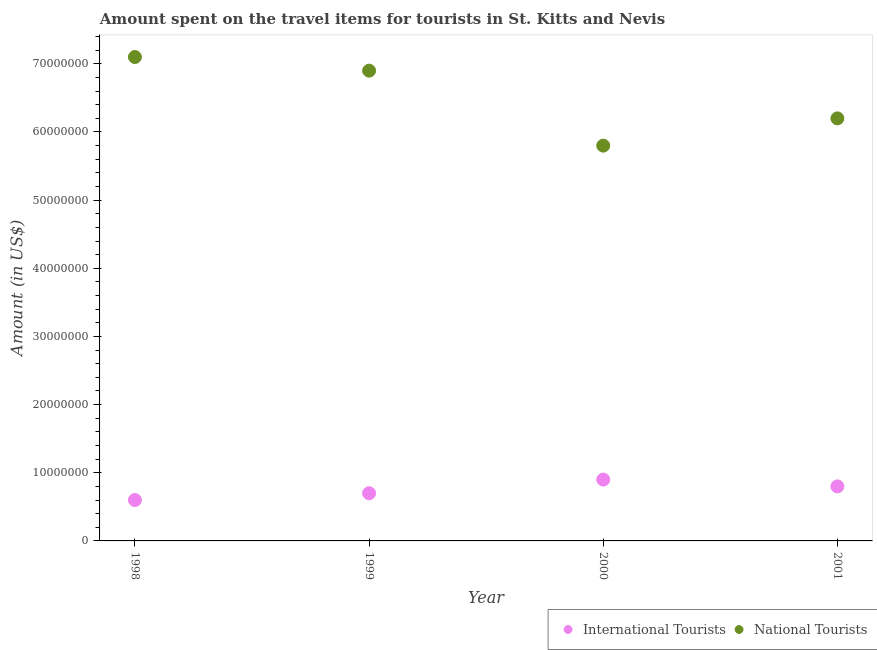How many different coloured dotlines are there?
Ensure brevity in your answer.  2. Is the number of dotlines equal to the number of legend labels?
Keep it short and to the point. Yes. What is the amount spent on travel items of international tourists in 1999?
Your answer should be very brief. 7.00e+06. Across all years, what is the maximum amount spent on travel items of international tourists?
Offer a terse response. 9.00e+06. Across all years, what is the minimum amount spent on travel items of international tourists?
Give a very brief answer. 6.00e+06. In which year was the amount spent on travel items of international tourists minimum?
Your answer should be compact. 1998. What is the total amount spent on travel items of national tourists in the graph?
Provide a succinct answer. 2.60e+08. What is the difference between the amount spent on travel items of national tourists in 1999 and that in 2000?
Keep it short and to the point. 1.10e+07. What is the difference between the amount spent on travel items of international tourists in 2001 and the amount spent on travel items of national tourists in 1998?
Keep it short and to the point. -6.30e+07. What is the average amount spent on travel items of international tourists per year?
Provide a succinct answer. 7.50e+06. In the year 1998, what is the difference between the amount spent on travel items of international tourists and amount spent on travel items of national tourists?
Provide a succinct answer. -6.50e+07. What is the ratio of the amount spent on travel items of international tourists in 1998 to that in 2000?
Ensure brevity in your answer.  0.67. Is the amount spent on travel items of national tourists in 1998 less than that in 1999?
Your answer should be compact. No. What is the difference between the highest and the second highest amount spent on travel items of international tourists?
Offer a very short reply. 1.00e+06. What is the difference between the highest and the lowest amount spent on travel items of international tourists?
Offer a very short reply. 3.00e+06. In how many years, is the amount spent on travel items of national tourists greater than the average amount spent on travel items of national tourists taken over all years?
Offer a very short reply. 2. Does the amount spent on travel items of national tourists monotonically increase over the years?
Your response must be concise. No. How many years are there in the graph?
Offer a terse response. 4. Are the values on the major ticks of Y-axis written in scientific E-notation?
Provide a short and direct response. No. Does the graph contain grids?
Make the answer very short. No. Where does the legend appear in the graph?
Offer a very short reply. Bottom right. How are the legend labels stacked?
Keep it short and to the point. Horizontal. What is the title of the graph?
Ensure brevity in your answer.  Amount spent on the travel items for tourists in St. Kitts and Nevis. Does "Manufacturing industries and construction" appear as one of the legend labels in the graph?
Your response must be concise. No. What is the label or title of the X-axis?
Offer a terse response. Year. What is the Amount (in US$) in National Tourists in 1998?
Give a very brief answer. 7.10e+07. What is the Amount (in US$) in International Tourists in 1999?
Your answer should be very brief. 7.00e+06. What is the Amount (in US$) in National Tourists in 1999?
Offer a very short reply. 6.90e+07. What is the Amount (in US$) in International Tourists in 2000?
Make the answer very short. 9.00e+06. What is the Amount (in US$) of National Tourists in 2000?
Give a very brief answer. 5.80e+07. What is the Amount (in US$) of National Tourists in 2001?
Give a very brief answer. 6.20e+07. Across all years, what is the maximum Amount (in US$) in International Tourists?
Provide a succinct answer. 9.00e+06. Across all years, what is the maximum Amount (in US$) in National Tourists?
Offer a very short reply. 7.10e+07. Across all years, what is the minimum Amount (in US$) of International Tourists?
Your answer should be compact. 6.00e+06. Across all years, what is the minimum Amount (in US$) of National Tourists?
Offer a very short reply. 5.80e+07. What is the total Amount (in US$) of International Tourists in the graph?
Your response must be concise. 3.00e+07. What is the total Amount (in US$) of National Tourists in the graph?
Ensure brevity in your answer.  2.60e+08. What is the difference between the Amount (in US$) of National Tourists in 1998 and that in 1999?
Ensure brevity in your answer.  2.00e+06. What is the difference between the Amount (in US$) of International Tourists in 1998 and that in 2000?
Provide a succinct answer. -3.00e+06. What is the difference between the Amount (in US$) in National Tourists in 1998 and that in 2000?
Your response must be concise. 1.30e+07. What is the difference between the Amount (in US$) in International Tourists in 1998 and that in 2001?
Your answer should be compact. -2.00e+06. What is the difference between the Amount (in US$) of National Tourists in 1998 and that in 2001?
Ensure brevity in your answer.  9.00e+06. What is the difference between the Amount (in US$) in International Tourists in 1999 and that in 2000?
Keep it short and to the point. -2.00e+06. What is the difference between the Amount (in US$) of National Tourists in 1999 and that in 2000?
Your answer should be very brief. 1.10e+07. What is the difference between the Amount (in US$) of International Tourists in 1999 and that in 2001?
Your response must be concise. -1.00e+06. What is the difference between the Amount (in US$) in National Tourists in 1999 and that in 2001?
Your answer should be very brief. 7.00e+06. What is the difference between the Amount (in US$) of International Tourists in 2000 and that in 2001?
Provide a short and direct response. 1.00e+06. What is the difference between the Amount (in US$) of International Tourists in 1998 and the Amount (in US$) of National Tourists in 1999?
Your answer should be compact. -6.30e+07. What is the difference between the Amount (in US$) of International Tourists in 1998 and the Amount (in US$) of National Tourists in 2000?
Your response must be concise. -5.20e+07. What is the difference between the Amount (in US$) in International Tourists in 1998 and the Amount (in US$) in National Tourists in 2001?
Your answer should be very brief. -5.60e+07. What is the difference between the Amount (in US$) of International Tourists in 1999 and the Amount (in US$) of National Tourists in 2000?
Provide a short and direct response. -5.10e+07. What is the difference between the Amount (in US$) in International Tourists in 1999 and the Amount (in US$) in National Tourists in 2001?
Your response must be concise. -5.50e+07. What is the difference between the Amount (in US$) in International Tourists in 2000 and the Amount (in US$) in National Tourists in 2001?
Your response must be concise. -5.30e+07. What is the average Amount (in US$) in International Tourists per year?
Keep it short and to the point. 7.50e+06. What is the average Amount (in US$) of National Tourists per year?
Give a very brief answer. 6.50e+07. In the year 1998, what is the difference between the Amount (in US$) in International Tourists and Amount (in US$) in National Tourists?
Your answer should be very brief. -6.50e+07. In the year 1999, what is the difference between the Amount (in US$) in International Tourists and Amount (in US$) in National Tourists?
Make the answer very short. -6.20e+07. In the year 2000, what is the difference between the Amount (in US$) of International Tourists and Amount (in US$) of National Tourists?
Keep it short and to the point. -4.90e+07. In the year 2001, what is the difference between the Amount (in US$) of International Tourists and Amount (in US$) of National Tourists?
Offer a very short reply. -5.40e+07. What is the ratio of the Amount (in US$) in International Tourists in 1998 to that in 1999?
Offer a terse response. 0.86. What is the ratio of the Amount (in US$) of National Tourists in 1998 to that in 2000?
Offer a very short reply. 1.22. What is the ratio of the Amount (in US$) of National Tourists in 1998 to that in 2001?
Give a very brief answer. 1.15. What is the ratio of the Amount (in US$) of National Tourists in 1999 to that in 2000?
Ensure brevity in your answer.  1.19. What is the ratio of the Amount (in US$) of National Tourists in 1999 to that in 2001?
Provide a short and direct response. 1.11. What is the ratio of the Amount (in US$) in International Tourists in 2000 to that in 2001?
Your answer should be very brief. 1.12. What is the ratio of the Amount (in US$) of National Tourists in 2000 to that in 2001?
Provide a succinct answer. 0.94. What is the difference between the highest and the lowest Amount (in US$) in International Tourists?
Offer a terse response. 3.00e+06. What is the difference between the highest and the lowest Amount (in US$) in National Tourists?
Give a very brief answer. 1.30e+07. 